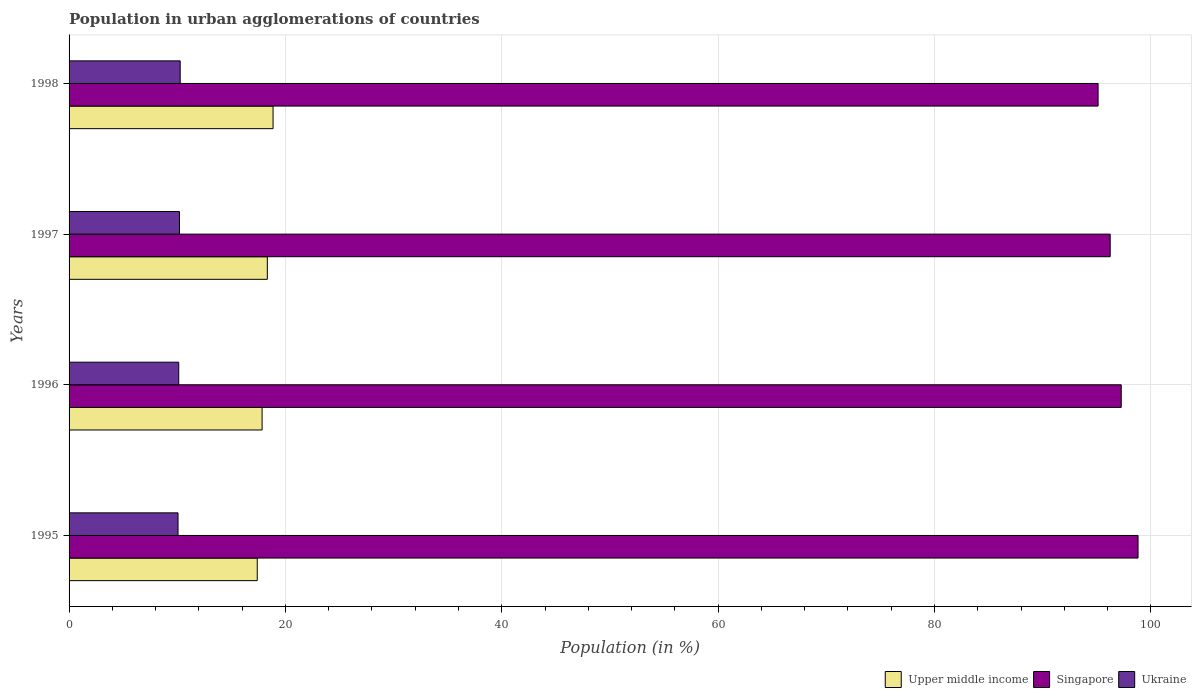Are the number of bars on each tick of the Y-axis equal?
Give a very brief answer. Yes. How many bars are there on the 1st tick from the top?
Your response must be concise. 3. What is the label of the 1st group of bars from the top?
Your answer should be compact. 1998. In how many cases, is the number of bars for a given year not equal to the number of legend labels?
Ensure brevity in your answer.  0. What is the percentage of population in urban agglomerations in Upper middle income in 1996?
Your answer should be compact. 17.84. Across all years, what is the maximum percentage of population in urban agglomerations in Ukraine?
Your answer should be compact. 10.27. Across all years, what is the minimum percentage of population in urban agglomerations in Singapore?
Provide a short and direct response. 95.12. What is the total percentage of population in urban agglomerations in Singapore in the graph?
Keep it short and to the point. 387.43. What is the difference between the percentage of population in urban agglomerations in Upper middle income in 1995 and that in 1998?
Provide a succinct answer. -1.46. What is the difference between the percentage of population in urban agglomerations in Singapore in 1998 and the percentage of population in urban agglomerations in Upper middle income in 1997?
Provide a short and direct response. 76.79. What is the average percentage of population in urban agglomerations in Ukraine per year?
Give a very brief answer. 10.17. In the year 1995, what is the difference between the percentage of population in urban agglomerations in Singapore and percentage of population in urban agglomerations in Upper middle income?
Provide a succinct answer. 81.42. What is the ratio of the percentage of population in urban agglomerations in Singapore in 1995 to that in 1996?
Provide a short and direct response. 1.02. Is the difference between the percentage of population in urban agglomerations in Singapore in 1995 and 1997 greater than the difference between the percentage of population in urban agglomerations in Upper middle income in 1995 and 1997?
Provide a short and direct response. Yes. What is the difference between the highest and the second highest percentage of population in urban agglomerations in Ukraine?
Keep it short and to the point. 0.07. What is the difference between the highest and the lowest percentage of population in urban agglomerations in Singapore?
Your answer should be compact. 3.69. What does the 2nd bar from the top in 1995 represents?
Give a very brief answer. Singapore. What does the 3rd bar from the bottom in 1995 represents?
Offer a terse response. Ukraine. How many bars are there?
Your answer should be very brief. 12. How many years are there in the graph?
Make the answer very short. 4. How are the legend labels stacked?
Give a very brief answer. Horizontal. What is the title of the graph?
Make the answer very short. Population in urban agglomerations of countries. What is the Population (in %) in Upper middle income in 1995?
Give a very brief answer. 17.39. What is the Population (in %) in Singapore in 1995?
Provide a succinct answer. 98.81. What is the Population (in %) of Ukraine in 1995?
Offer a terse response. 10.07. What is the Population (in %) of Upper middle income in 1996?
Give a very brief answer. 17.84. What is the Population (in %) in Singapore in 1996?
Provide a short and direct response. 97.26. What is the Population (in %) in Ukraine in 1996?
Give a very brief answer. 10.14. What is the Population (in %) in Upper middle income in 1997?
Provide a short and direct response. 18.33. What is the Population (in %) of Singapore in 1997?
Keep it short and to the point. 96.24. What is the Population (in %) of Ukraine in 1997?
Offer a terse response. 10.21. What is the Population (in %) of Upper middle income in 1998?
Make the answer very short. 18.86. What is the Population (in %) in Singapore in 1998?
Give a very brief answer. 95.12. What is the Population (in %) in Ukraine in 1998?
Provide a short and direct response. 10.27. Across all years, what is the maximum Population (in %) in Upper middle income?
Make the answer very short. 18.86. Across all years, what is the maximum Population (in %) in Singapore?
Your response must be concise. 98.81. Across all years, what is the maximum Population (in %) in Ukraine?
Your answer should be very brief. 10.27. Across all years, what is the minimum Population (in %) of Upper middle income?
Your answer should be very brief. 17.39. Across all years, what is the minimum Population (in %) of Singapore?
Ensure brevity in your answer.  95.12. Across all years, what is the minimum Population (in %) of Ukraine?
Give a very brief answer. 10.07. What is the total Population (in %) of Upper middle income in the graph?
Your answer should be very brief. 72.42. What is the total Population (in %) of Singapore in the graph?
Give a very brief answer. 387.43. What is the total Population (in %) of Ukraine in the graph?
Provide a succinct answer. 40.69. What is the difference between the Population (in %) in Upper middle income in 1995 and that in 1996?
Ensure brevity in your answer.  -0.45. What is the difference between the Population (in %) of Singapore in 1995 and that in 1996?
Make the answer very short. 1.55. What is the difference between the Population (in %) of Ukraine in 1995 and that in 1996?
Ensure brevity in your answer.  -0.07. What is the difference between the Population (in %) in Upper middle income in 1995 and that in 1997?
Offer a very short reply. -0.93. What is the difference between the Population (in %) of Singapore in 1995 and that in 1997?
Offer a very short reply. 2.58. What is the difference between the Population (in %) in Ukraine in 1995 and that in 1997?
Your response must be concise. -0.13. What is the difference between the Population (in %) in Upper middle income in 1995 and that in 1998?
Provide a short and direct response. -1.46. What is the difference between the Population (in %) of Singapore in 1995 and that in 1998?
Give a very brief answer. 3.69. What is the difference between the Population (in %) of Ukraine in 1995 and that in 1998?
Your answer should be compact. -0.2. What is the difference between the Population (in %) in Upper middle income in 1996 and that in 1997?
Provide a short and direct response. -0.48. What is the difference between the Population (in %) in Ukraine in 1996 and that in 1997?
Your response must be concise. -0.07. What is the difference between the Population (in %) of Upper middle income in 1996 and that in 1998?
Your response must be concise. -1.01. What is the difference between the Population (in %) of Singapore in 1996 and that in 1998?
Provide a short and direct response. 2.14. What is the difference between the Population (in %) in Ukraine in 1996 and that in 1998?
Provide a short and direct response. -0.14. What is the difference between the Population (in %) of Upper middle income in 1997 and that in 1998?
Offer a very short reply. -0.53. What is the difference between the Population (in %) of Singapore in 1997 and that in 1998?
Offer a terse response. 1.12. What is the difference between the Population (in %) in Ukraine in 1997 and that in 1998?
Offer a terse response. -0.07. What is the difference between the Population (in %) in Upper middle income in 1995 and the Population (in %) in Singapore in 1996?
Provide a succinct answer. -79.86. What is the difference between the Population (in %) in Upper middle income in 1995 and the Population (in %) in Ukraine in 1996?
Your answer should be very brief. 7.26. What is the difference between the Population (in %) in Singapore in 1995 and the Population (in %) in Ukraine in 1996?
Provide a succinct answer. 88.68. What is the difference between the Population (in %) of Upper middle income in 1995 and the Population (in %) of Singapore in 1997?
Your response must be concise. -78.84. What is the difference between the Population (in %) of Upper middle income in 1995 and the Population (in %) of Ukraine in 1997?
Give a very brief answer. 7.19. What is the difference between the Population (in %) of Singapore in 1995 and the Population (in %) of Ukraine in 1997?
Offer a very short reply. 88.61. What is the difference between the Population (in %) of Upper middle income in 1995 and the Population (in %) of Singapore in 1998?
Offer a very short reply. -77.72. What is the difference between the Population (in %) of Upper middle income in 1995 and the Population (in %) of Ukraine in 1998?
Offer a very short reply. 7.12. What is the difference between the Population (in %) of Singapore in 1995 and the Population (in %) of Ukraine in 1998?
Keep it short and to the point. 88.54. What is the difference between the Population (in %) in Upper middle income in 1996 and the Population (in %) in Singapore in 1997?
Provide a succinct answer. -78.39. What is the difference between the Population (in %) of Upper middle income in 1996 and the Population (in %) of Ukraine in 1997?
Ensure brevity in your answer.  7.64. What is the difference between the Population (in %) of Singapore in 1996 and the Population (in %) of Ukraine in 1997?
Keep it short and to the point. 87.05. What is the difference between the Population (in %) in Upper middle income in 1996 and the Population (in %) in Singapore in 1998?
Provide a short and direct response. -77.28. What is the difference between the Population (in %) in Upper middle income in 1996 and the Population (in %) in Ukraine in 1998?
Provide a succinct answer. 7.57. What is the difference between the Population (in %) in Singapore in 1996 and the Population (in %) in Ukraine in 1998?
Offer a very short reply. 86.99. What is the difference between the Population (in %) of Upper middle income in 1997 and the Population (in %) of Singapore in 1998?
Your answer should be compact. -76.79. What is the difference between the Population (in %) in Upper middle income in 1997 and the Population (in %) in Ukraine in 1998?
Your answer should be very brief. 8.05. What is the difference between the Population (in %) in Singapore in 1997 and the Population (in %) in Ukraine in 1998?
Provide a succinct answer. 85.96. What is the average Population (in %) of Upper middle income per year?
Make the answer very short. 18.11. What is the average Population (in %) of Singapore per year?
Your answer should be very brief. 96.86. What is the average Population (in %) in Ukraine per year?
Make the answer very short. 10.17. In the year 1995, what is the difference between the Population (in %) of Upper middle income and Population (in %) of Singapore?
Make the answer very short. -81.42. In the year 1995, what is the difference between the Population (in %) in Upper middle income and Population (in %) in Ukraine?
Ensure brevity in your answer.  7.32. In the year 1995, what is the difference between the Population (in %) of Singapore and Population (in %) of Ukraine?
Give a very brief answer. 88.74. In the year 1996, what is the difference between the Population (in %) in Upper middle income and Population (in %) in Singapore?
Make the answer very short. -79.42. In the year 1996, what is the difference between the Population (in %) of Upper middle income and Population (in %) of Ukraine?
Make the answer very short. 7.71. In the year 1996, what is the difference between the Population (in %) of Singapore and Population (in %) of Ukraine?
Offer a terse response. 87.12. In the year 1997, what is the difference between the Population (in %) of Upper middle income and Population (in %) of Singapore?
Offer a very short reply. -77.91. In the year 1997, what is the difference between the Population (in %) in Upper middle income and Population (in %) in Ukraine?
Offer a terse response. 8.12. In the year 1997, what is the difference between the Population (in %) of Singapore and Population (in %) of Ukraine?
Your answer should be very brief. 86.03. In the year 1998, what is the difference between the Population (in %) in Upper middle income and Population (in %) in Singapore?
Your answer should be compact. -76.26. In the year 1998, what is the difference between the Population (in %) of Upper middle income and Population (in %) of Ukraine?
Provide a short and direct response. 8.58. In the year 1998, what is the difference between the Population (in %) of Singapore and Population (in %) of Ukraine?
Keep it short and to the point. 84.85. What is the ratio of the Population (in %) of Upper middle income in 1995 to that in 1996?
Your answer should be compact. 0.97. What is the ratio of the Population (in %) in Singapore in 1995 to that in 1996?
Offer a terse response. 1.02. What is the ratio of the Population (in %) in Ukraine in 1995 to that in 1996?
Provide a short and direct response. 0.99. What is the ratio of the Population (in %) of Upper middle income in 1995 to that in 1997?
Your response must be concise. 0.95. What is the ratio of the Population (in %) in Singapore in 1995 to that in 1997?
Offer a terse response. 1.03. What is the ratio of the Population (in %) in Ukraine in 1995 to that in 1997?
Offer a very short reply. 0.99. What is the ratio of the Population (in %) in Upper middle income in 1995 to that in 1998?
Provide a short and direct response. 0.92. What is the ratio of the Population (in %) of Singapore in 1995 to that in 1998?
Make the answer very short. 1.04. What is the ratio of the Population (in %) in Ukraine in 1995 to that in 1998?
Your response must be concise. 0.98. What is the ratio of the Population (in %) of Upper middle income in 1996 to that in 1997?
Ensure brevity in your answer.  0.97. What is the ratio of the Population (in %) of Singapore in 1996 to that in 1997?
Offer a very short reply. 1.01. What is the ratio of the Population (in %) of Ukraine in 1996 to that in 1997?
Your response must be concise. 0.99. What is the ratio of the Population (in %) of Upper middle income in 1996 to that in 1998?
Your answer should be very brief. 0.95. What is the ratio of the Population (in %) of Singapore in 1996 to that in 1998?
Your answer should be compact. 1.02. What is the ratio of the Population (in %) in Ukraine in 1996 to that in 1998?
Your answer should be very brief. 0.99. What is the ratio of the Population (in %) in Upper middle income in 1997 to that in 1998?
Provide a short and direct response. 0.97. What is the ratio of the Population (in %) of Singapore in 1997 to that in 1998?
Your answer should be compact. 1.01. What is the ratio of the Population (in %) in Ukraine in 1997 to that in 1998?
Your response must be concise. 0.99. What is the difference between the highest and the second highest Population (in %) in Upper middle income?
Provide a short and direct response. 0.53. What is the difference between the highest and the second highest Population (in %) in Singapore?
Ensure brevity in your answer.  1.55. What is the difference between the highest and the second highest Population (in %) of Ukraine?
Make the answer very short. 0.07. What is the difference between the highest and the lowest Population (in %) of Upper middle income?
Give a very brief answer. 1.46. What is the difference between the highest and the lowest Population (in %) in Singapore?
Your response must be concise. 3.69. What is the difference between the highest and the lowest Population (in %) of Ukraine?
Provide a short and direct response. 0.2. 